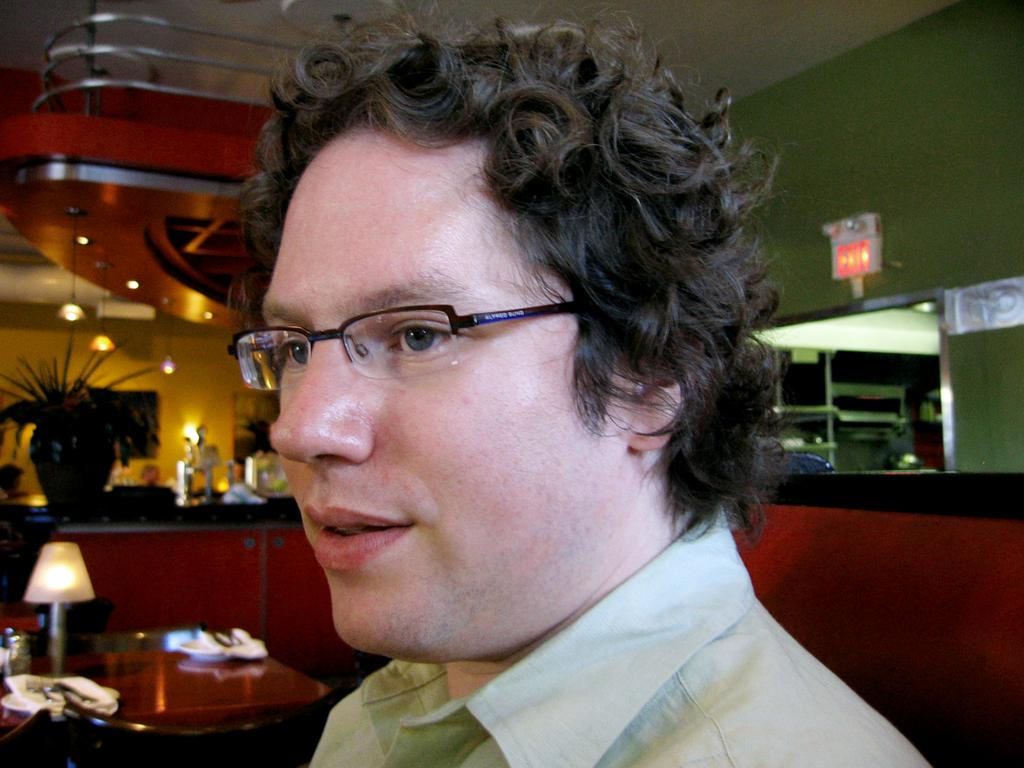What is the main subject in the middle of the image? There is a man sitting in the middle of the image. What can be seen on the man's face? The man is wearing glasses (specs). What object is present in the image that provides light? There is a lamp in the image. What color is the wall on the right side of the image? The wall on the right side of the image is green-colored. How does the man show respect to his family in the image? There is no information about the man's family or any actions related to respect in the image. What type of earthquake can be seen in the image? There is no earthquake present in the image; it features a man sitting with glasses, a lamp, and a green-colored wall. 